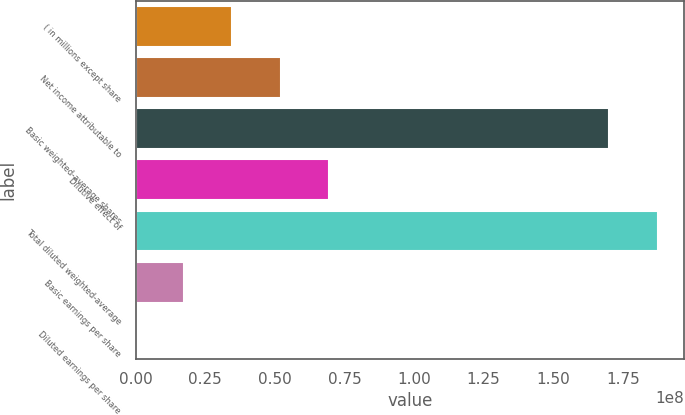Convert chart. <chart><loc_0><loc_0><loc_500><loc_500><bar_chart><fcel>( in millions except share<fcel>Net income attributable to<fcel>Basic weighted-average shares<fcel>Dilutive effect of<fcel>Total diluted weighted-average<fcel>Basic earnings per share<fcel>Diluted earnings per share<nl><fcel>3.47658e+07<fcel>5.21487e+07<fcel>1.70186e+08<fcel>6.95316e+07<fcel>1.87569e+08<fcel>1.73829e+07<fcel>16.87<nl></chart> 